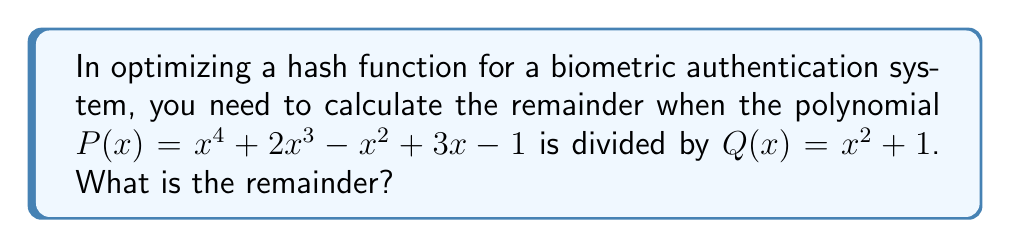What is the answer to this math problem? To find the remainder when $P(x)$ is divided by $Q(x)$, we can use polynomial long division:

1) First, divide $x^4$ by $x^2$:
   $x^4 \div (x^2) = x^2$
   Multiply: $(x^2)(x^2 + 1) = x^4 + x^2$
   Subtract: $x^4 + 2x^3 - x^2 + 3x - 1 - (x^4 + x^2) = 2x^3 - 2x^2 + 3x - 1$

2) Now divide $2x^3$ by $x^2$:
   $2x^3 \div (x^2) = 2x$
   Multiply: $(2x)(x^2 + 1) = 2x^3 + 2x$
   Subtract: $2x^3 - 2x^2 + 3x - 1 - (2x^3 + 2x) = -2x^2 + x - 1$

3) The degree of $-2x^2 + x - 1$ is less than the degree of $x^2 + 1$, so we stop here.

Therefore, the remainder is $-2x^2 + x - 1$.

In the context of hash function optimization, this remainder could be used as part of a reduction step to ensure the hash output falls within a desired range, enhancing the efficiency of the biometric authentication system.
Answer: $-2x^2 + x - 1$ 